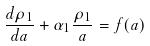<formula> <loc_0><loc_0><loc_500><loc_500>\frac { d \rho _ { 1 } } { d a } + \alpha _ { 1 } \frac { \rho _ { 1 } } { a } = f ( a )</formula> 